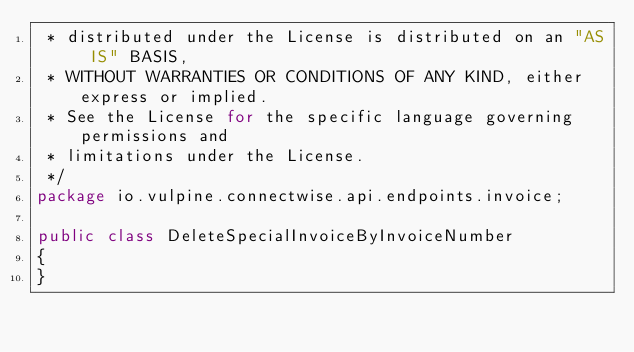<code> <loc_0><loc_0><loc_500><loc_500><_Java_> * distributed under the License is distributed on an "AS IS" BASIS,
 * WITHOUT WARRANTIES OR CONDITIONS OF ANY KIND, either express or implied.
 * See the License for the specific language governing permissions and
 * limitations under the License.
 */
package io.vulpine.connectwise.api.endpoints.invoice;

public class DeleteSpecialInvoiceByInvoiceNumber
{
}
</code> 